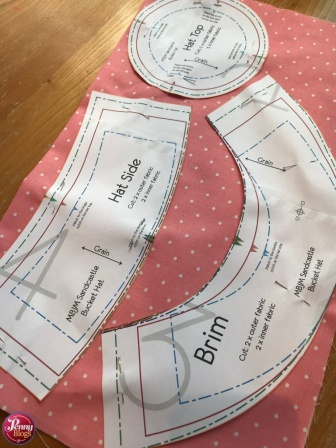Imagine the story behind this scene. Who might be making this hat and why? In a quaint little atelier bathed in the golden afternoon light, sits a young milliner named Clara. Clara, with her boundless creativity and love for vintage fashion, is preparing to craft a special hat for the annual village fête. The pink polka-dotted fabric reflects her whimsical taste and the paper patterns scattered meticulously on the table reveal her attention to detail. Each piece is carefully placed as she envisions the final creation—a beautiful sun hat that will not only keep the wearer cool but will also be the talk of the fête, a blend of functionality and timeless charm. What kind of tools and materials might Clara use to turn these patterns into a finished hat? To transform these patterns into a finished hat, Clara would use a variety of tools and materials. Her work area would likely include sharp fabric scissors for precise cuts, several types of needles for hand sewing and possibly a sewing machine for more robust stitching. She’d have a collection of colorful threads and pins to hold fabric pieces in place. Other materials might include interfacing to give the hat structure, and decorative elements such as ribbons, buttons, or lace to add a unique touch. Clara would also need measuring tapes to ensure everything fits perfectly and possibly an iron to press seams and fabric for a professional finish. 